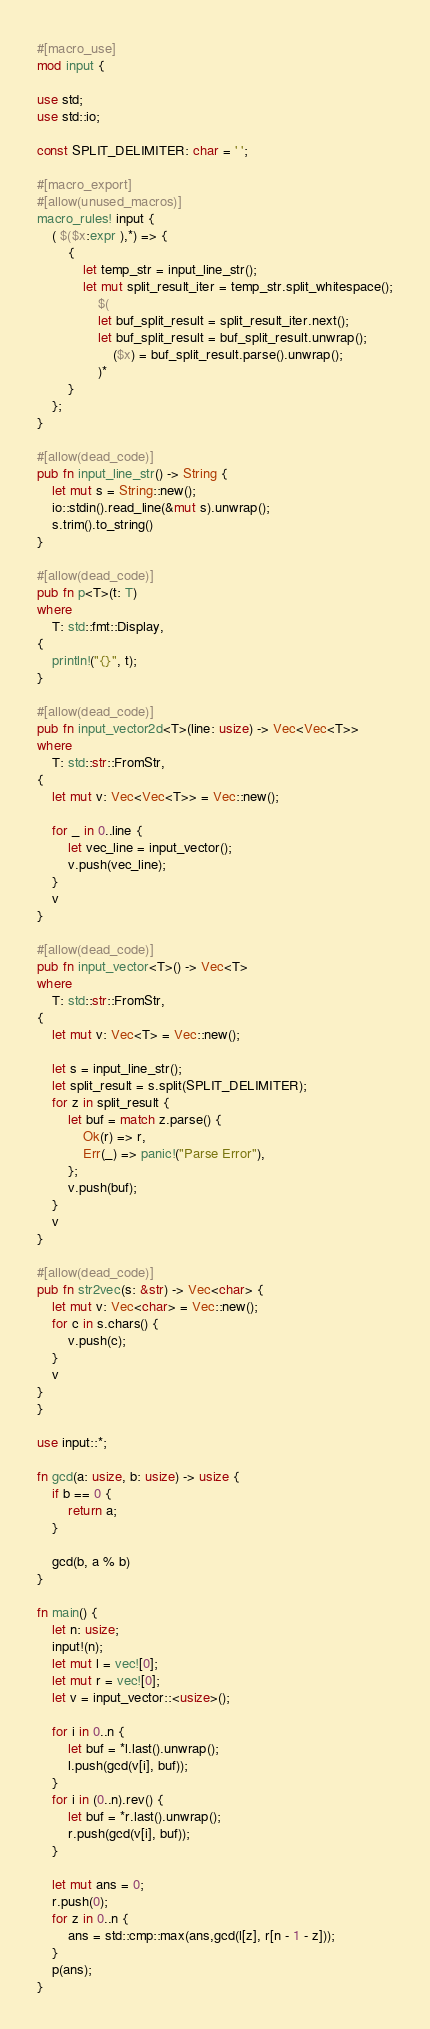Convert code to text. <code><loc_0><loc_0><loc_500><loc_500><_Rust_>#[macro_use]
mod input {

use std;
use std::io;

const SPLIT_DELIMITER: char = ' ';

#[macro_export]
#[allow(unused_macros)]
macro_rules! input {
    ( $($x:expr ),*) => {
        {
            let temp_str = input_line_str();
            let mut split_result_iter = temp_str.split_whitespace();
                $(
                let buf_split_result = split_result_iter.next();
                let buf_split_result = buf_split_result.unwrap();
                    ($x) = buf_split_result.parse().unwrap();
                )*
        }
    };
}

#[allow(dead_code)]
pub fn input_line_str() -> String {
    let mut s = String::new();
    io::stdin().read_line(&mut s).unwrap();
    s.trim().to_string()
}

#[allow(dead_code)]
pub fn p<T>(t: T)
where
    T: std::fmt::Display,
{
    println!("{}", t);
}

#[allow(dead_code)]
pub fn input_vector2d<T>(line: usize) -> Vec<Vec<T>>
where
    T: std::str::FromStr,
{
    let mut v: Vec<Vec<T>> = Vec::new();

    for _ in 0..line {
        let vec_line = input_vector();
        v.push(vec_line);
    }
    v
}

#[allow(dead_code)]
pub fn input_vector<T>() -> Vec<T>
where
    T: std::str::FromStr,
{
    let mut v: Vec<T> = Vec::new();

    let s = input_line_str();
    let split_result = s.split(SPLIT_DELIMITER);
    for z in split_result {
        let buf = match z.parse() {
            Ok(r) => r,
            Err(_) => panic!("Parse Error"),
        };
        v.push(buf);
    }
    v
}

#[allow(dead_code)]
pub fn str2vec(s: &str) -> Vec<char> {
    let mut v: Vec<char> = Vec::new();
    for c in s.chars() {
        v.push(c);
    }
    v
}
}

use input::*;

fn gcd(a: usize, b: usize) -> usize {
    if b == 0 {
        return a;
    }

    gcd(b, a % b)
}

fn main() {
    let n: usize;
    input!(n);
    let mut l = vec![0];
    let mut r = vec![0];
    let v = input_vector::<usize>();

    for i in 0..n {
        let buf = *l.last().unwrap();
        l.push(gcd(v[i], buf));
    }
    for i in (0..n).rev() {
        let buf = *r.last().unwrap();
        r.push(gcd(v[i], buf));
    }

    let mut ans = 0;
    r.push(0);
    for z in 0..n {
        ans = std::cmp::max(ans,gcd(l[z], r[n - 1 - z]));
    }
    p(ans);
}</code> 